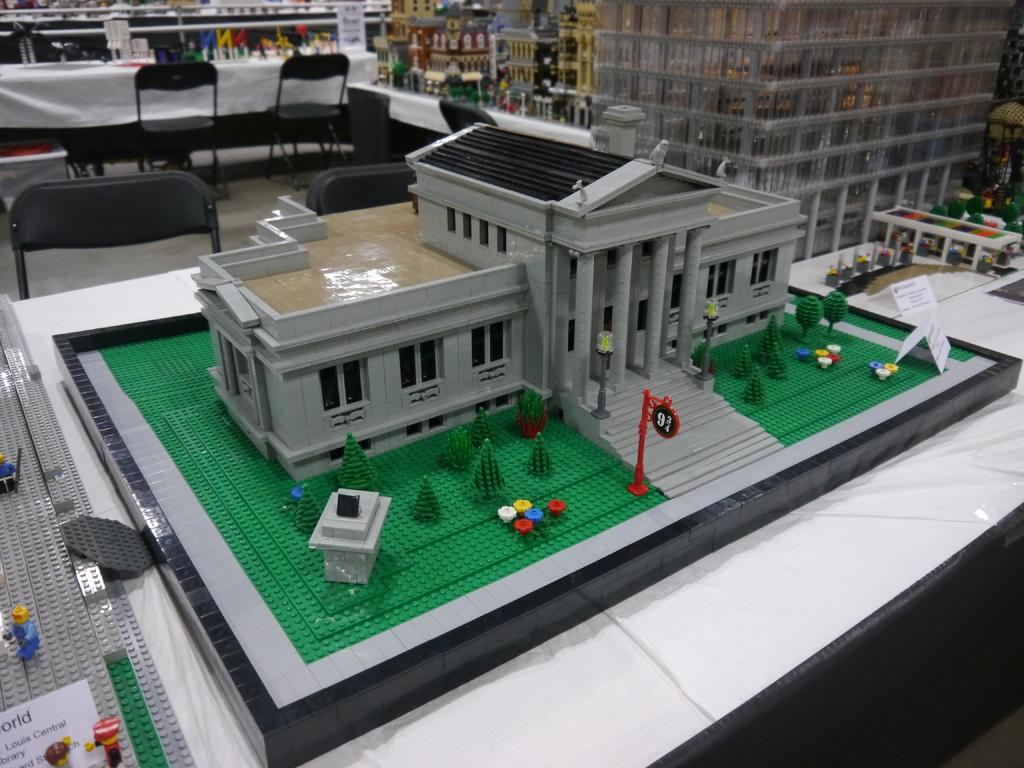What type of objects can be seen in the image? There are toys, chairs, tables with miniature buildings, and name boards in the image. What might people use to sit in the image? The chairs in the image can be used for sitting. What type of structures are on the tables in the image? The tables have miniature buildings on them. How can people identify their belongings in the image? The name boards in the image can help people identify their belongings. What can be seen in the background of the image? There are objects visible in the background of the image. What type of vegetable is being crushed in the image? There is no vegetable being crushed in the image. What type of sponge is being used to clean the toys in the image? There is no sponge visible in the image, and the toys do not appear to be dirty or in need of cleaning. 